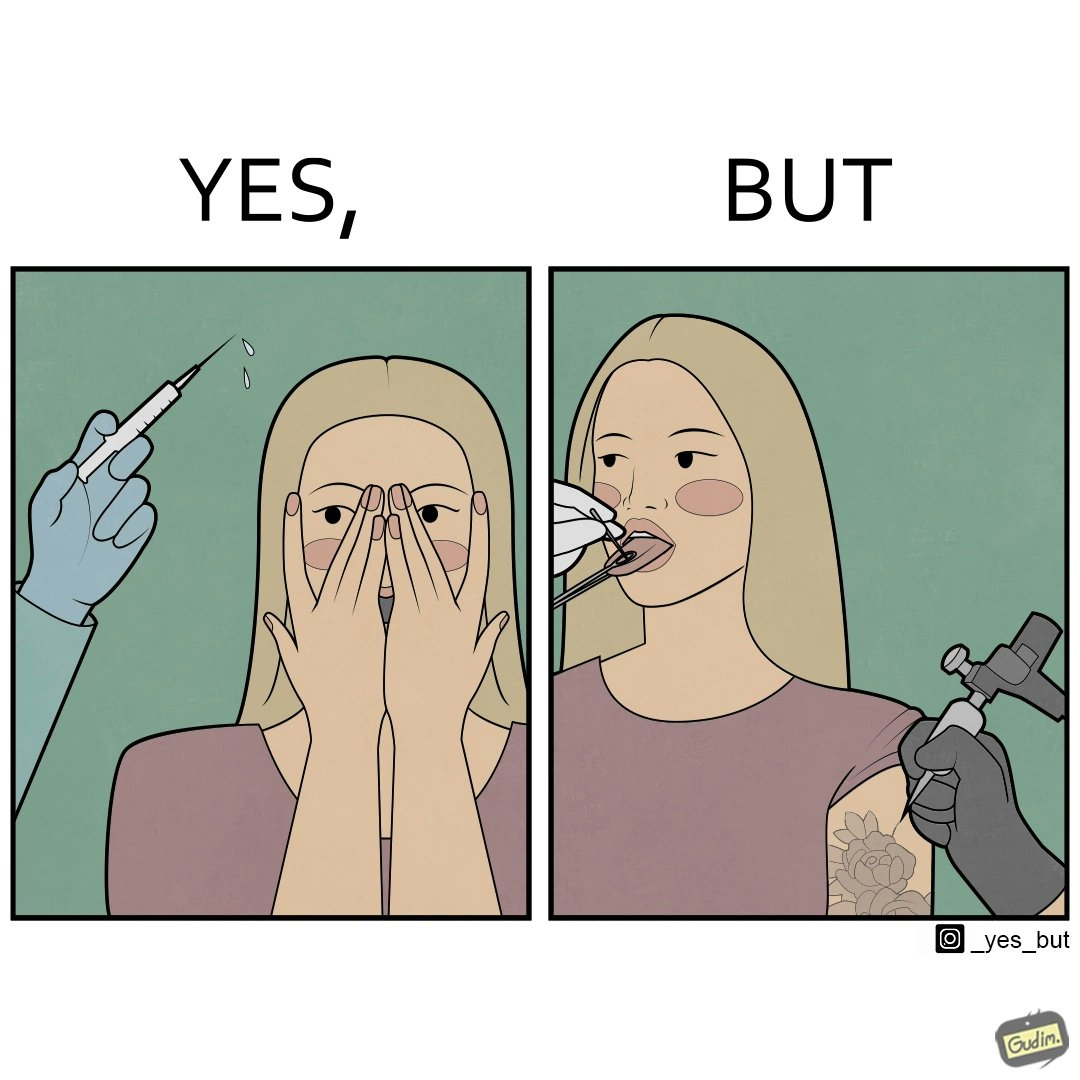What do you see in each half of this image? In the left part of the image: The iamge shows a woman scared of the syringe about to be used to inject her with medicine. In the right part of the image: The image shows a woman with her tongue out getting a piercing in her tongue. The image also shows shows the same woman getting tattoed on her left arm at the same time as getting  a piercing. 